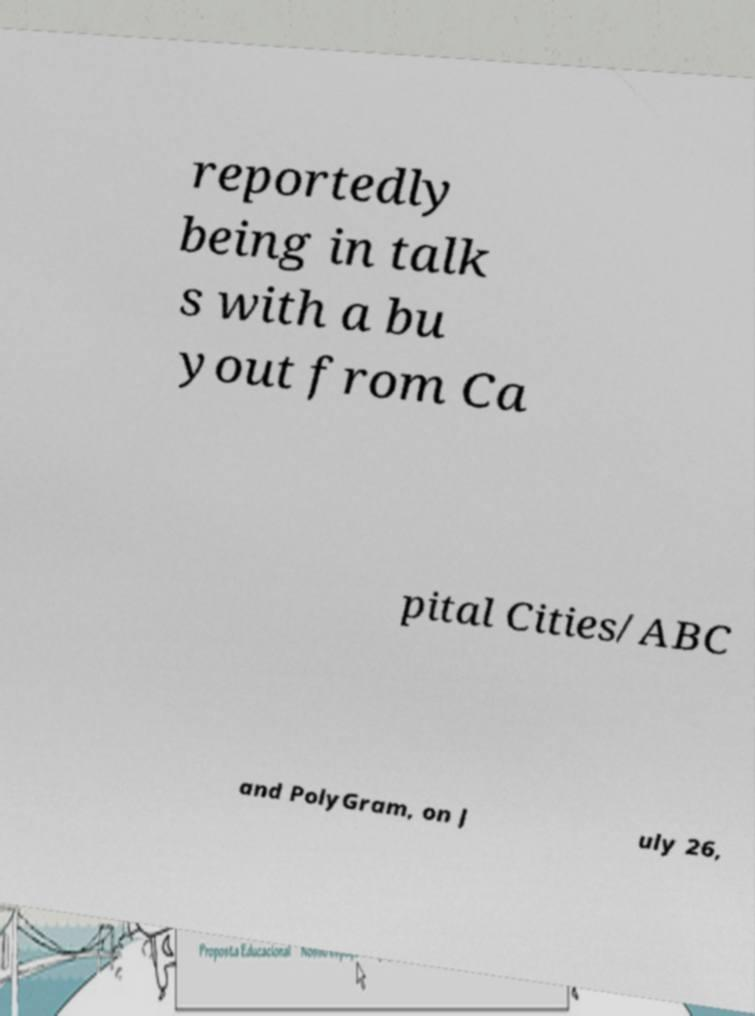Please identify and transcribe the text found in this image. reportedly being in talk s with a bu yout from Ca pital Cities/ABC and PolyGram, on J uly 26, 